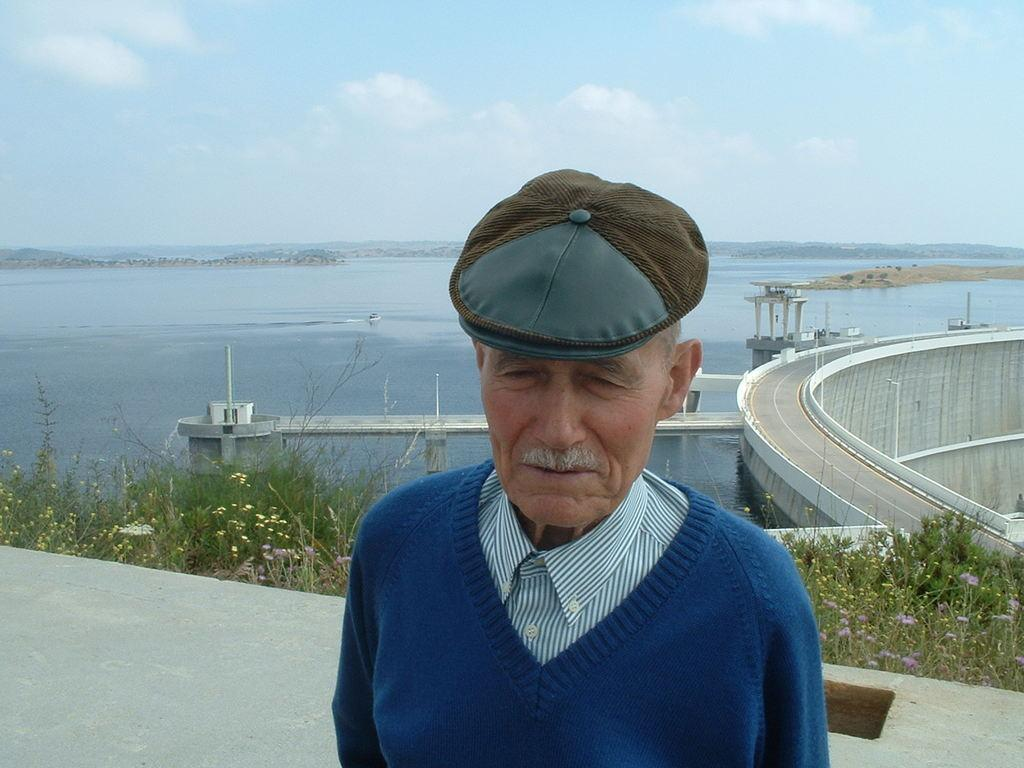What is the main subject of the image? There is a man standing in the image. What can be seen in the background of the image? There are plants, a road, and a river in the background of the image. What is visible above the background elements? The sky is visible in the image. What type of twig is being used as a caption for the image? There is no twig or caption present in the image. How many wheels can be seen in the image? There are no wheels visible in the image. 